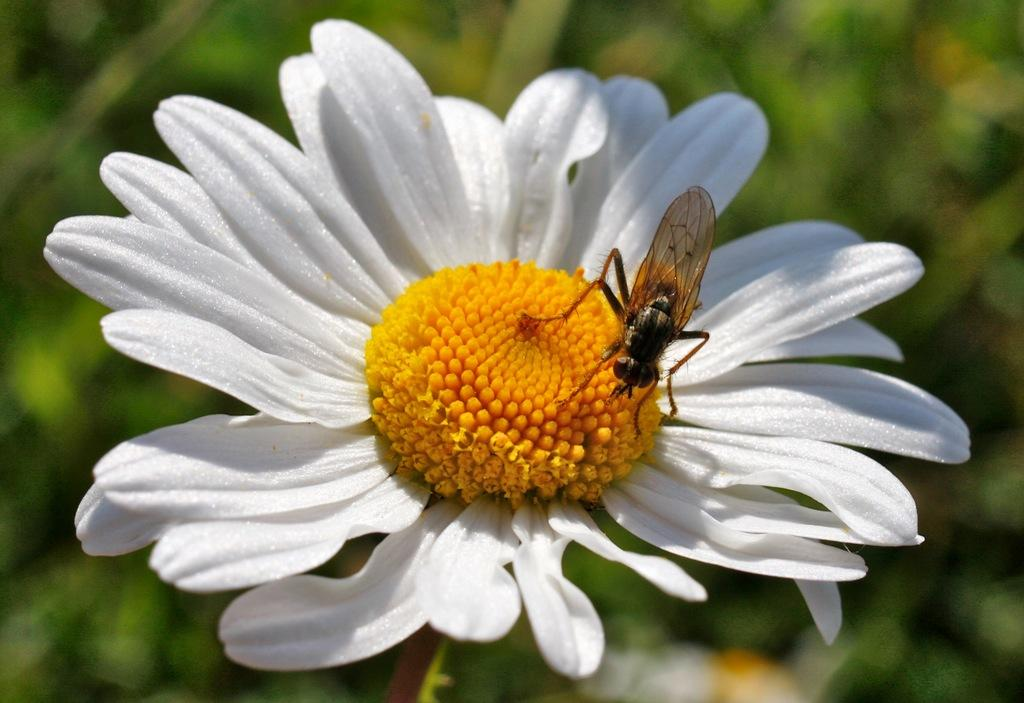What is the main subject of the image? There is a flower in the image. Is there anything else present on the flower? Yes, there is an insect on the flower. Can you describe the background of the image? The background of the image is blurred. What type of wristwatch is the insect wearing in the image? There is no wristwatch present in the image, as insects do not wear wristwatches. 